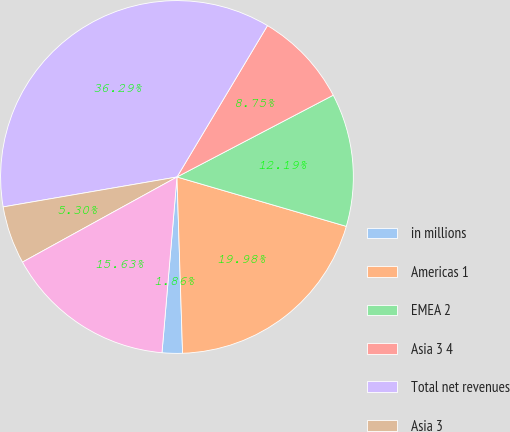<chart> <loc_0><loc_0><loc_500><loc_500><pie_chart><fcel>in millions<fcel>Americas 1<fcel>EMEA 2<fcel>Asia 3 4<fcel>Total net revenues<fcel>Asia 3<fcel>Subtotal<nl><fcel>1.86%<fcel>19.98%<fcel>12.19%<fcel>8.75%<fcel>36.29%<fcel>5.3%<fcel>15.63%<nl></chart> 